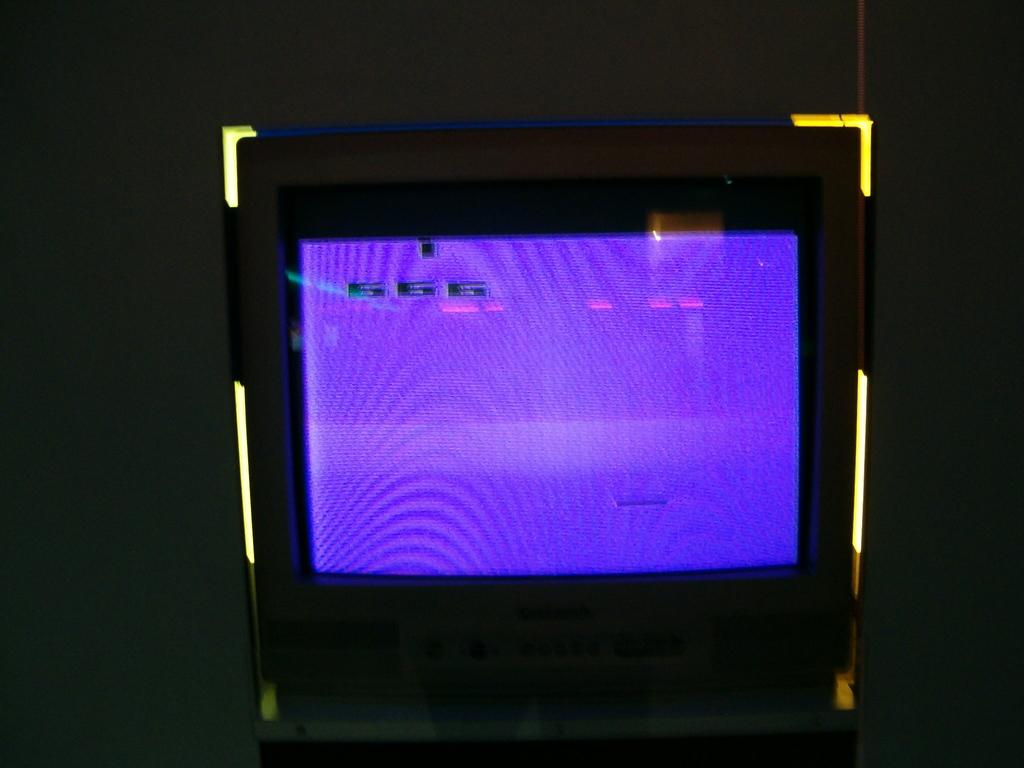What is the main object in the center of the image? There is a television in the center of the image. How is the television positioned in the image? The television appears to be attached to the wall. What type of stick can be seen leaning against the television in the image? There is no stick present in the image; it only features a television attached to the wall. 